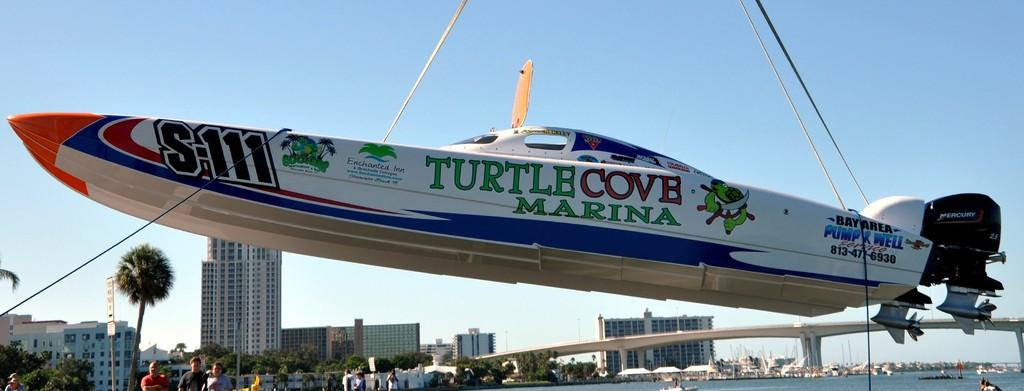<image>
Share a concise interpretation of the image provided. A cigarette boat with Turtle Cove Marina written on the side. 